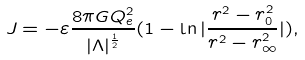Convert formula to latex. <formula><loc_0><loc_0><loc_500><loc_500>J = - \varepsilon \frac { 8 \pi G Q _ { e } ^ { 2 } } { | \Lambda | ^ { \frac { 1 } { 2 } } } ( 1 - \ln | \frac { r ^ { 2 } - r _ { 0 } ^ { 2 } } { r ^ { 2 } - r _ { \infty } ^ { 2 } } | ) ,</formula> 